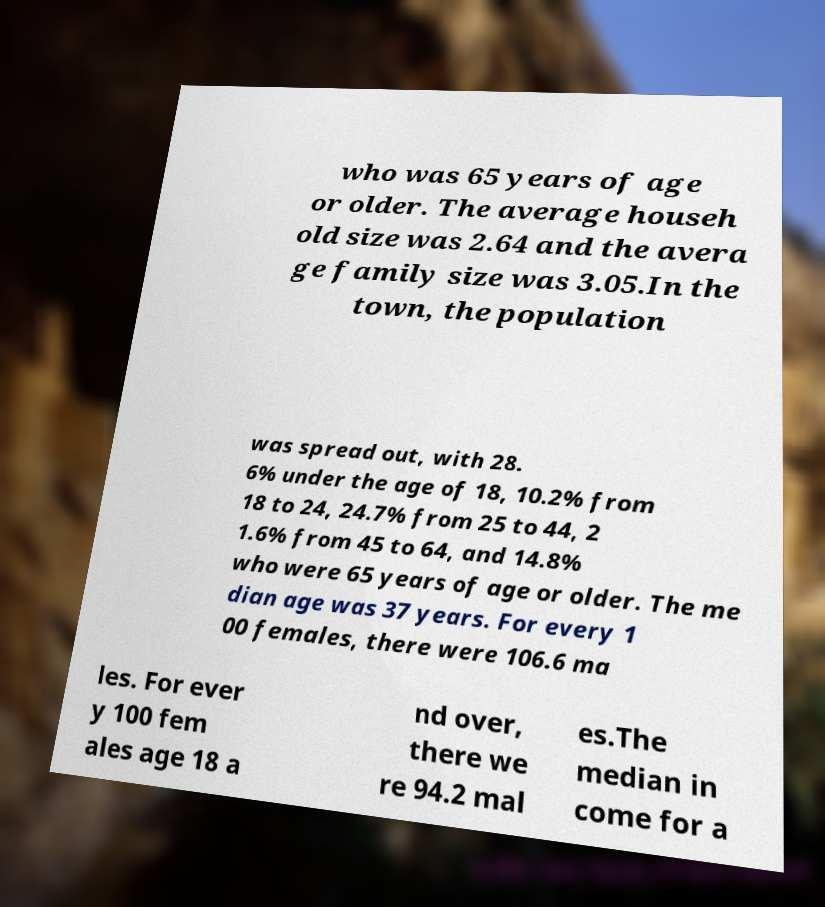Could you assist in decoding the text presented in this image and type it out clearly? who was 65 years of age or older. The average househ old size was 2.64 and the avera ge family size was 3.05.In the town, the population was spread out, with 28. 6% under the age of 18, 10.2% from 18 to 24, 24.7% from 25 to 44, 2 1.6% from 45 to 64, and 14.8% who were 65 years of age or older. The me dian age was 37 years. For every 1 00 females, there were 106.6 ma les. For ever y 100 fem ales age 18 a nd over, there we re 94.2 mal es.The median in come for a 